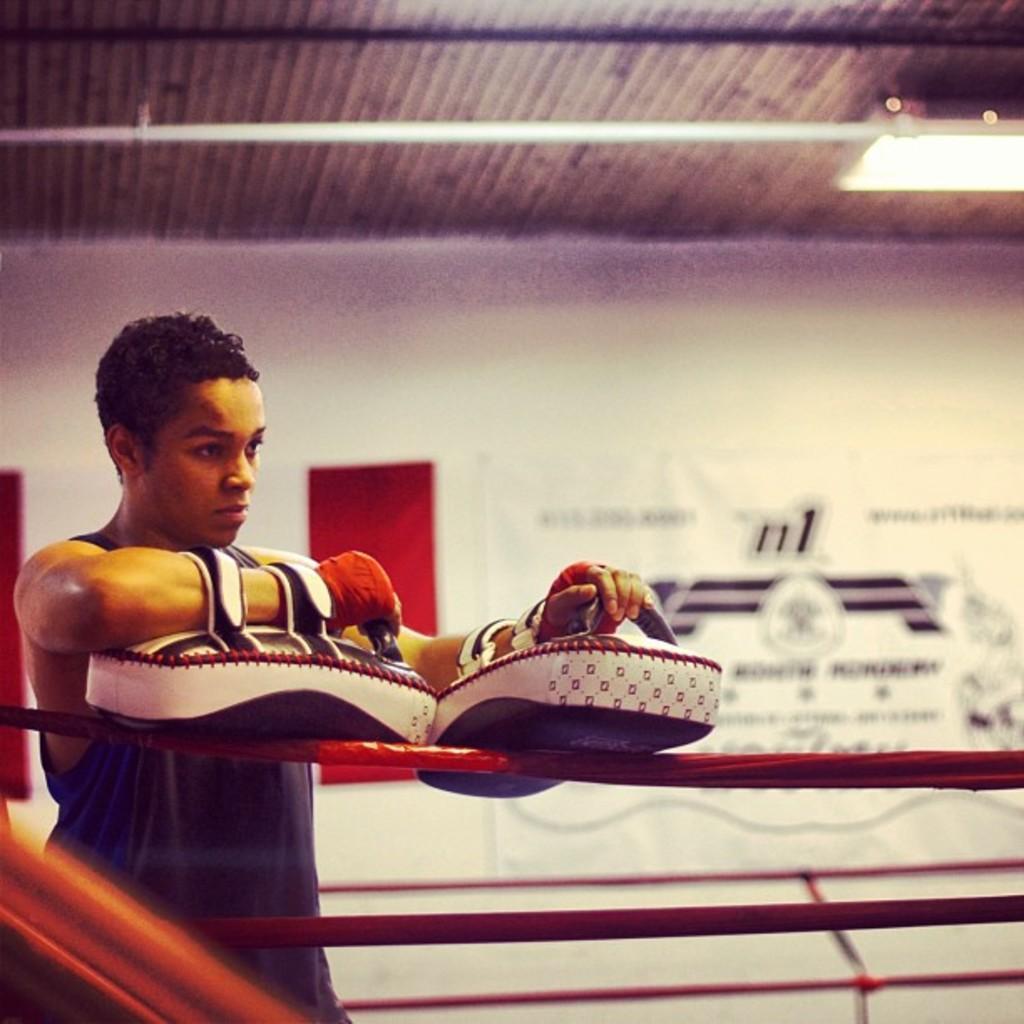Describe this image in one or two sentences. In this image we can see a person wearing the arm pads on his hands. In the foreground we can see some ropes. In the background, we can see a banner with some text. At the top of the image we can see lights and a pole on the roof. 